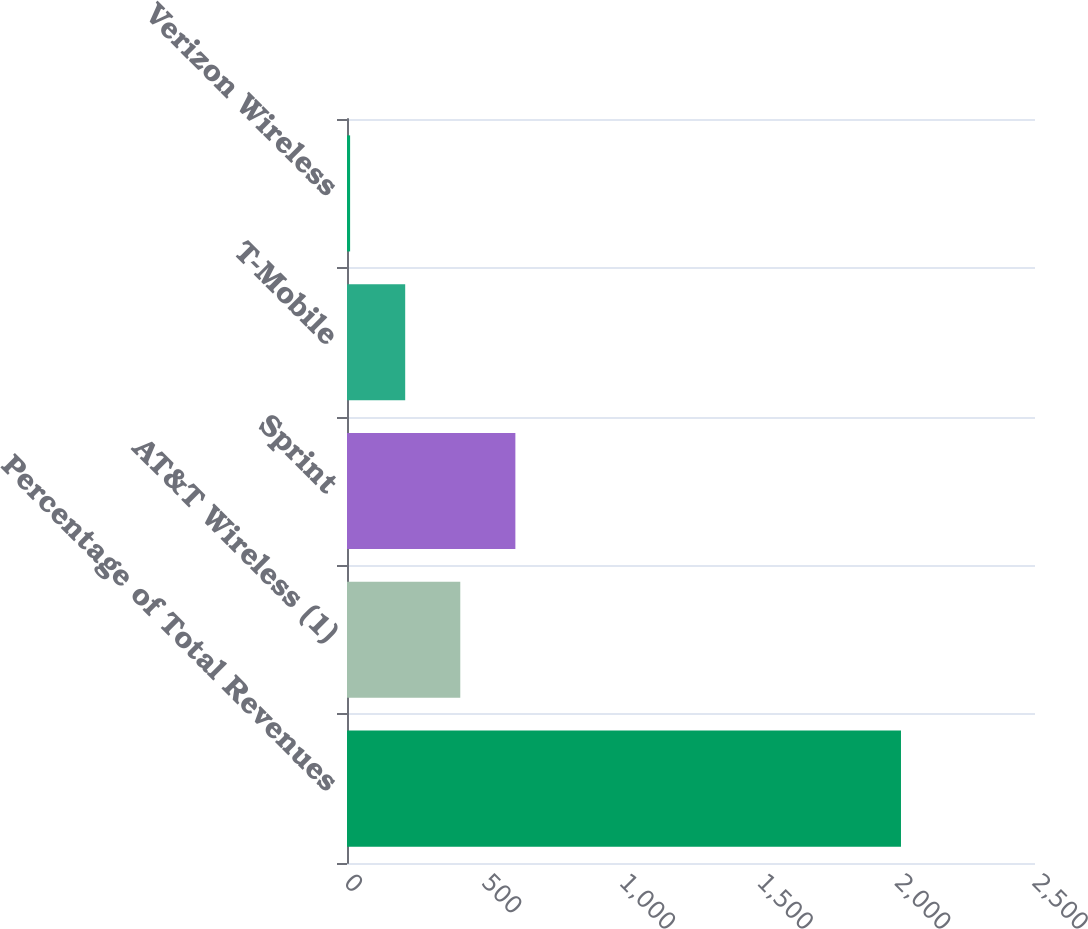<chart> <loc_0><loc_0><loc_500><loc_500><bar_chart><fcel>Percentage of Total Revenues<fcel>AT&T Wireless (1)<fcel>Sprint<fcel>T-Mobile<fcel>Verizon Wireless<nl><fcel>2013<fcel>411.64<fcel>611.81<fcel>211.47<fcel>11.3<nl></chart> 